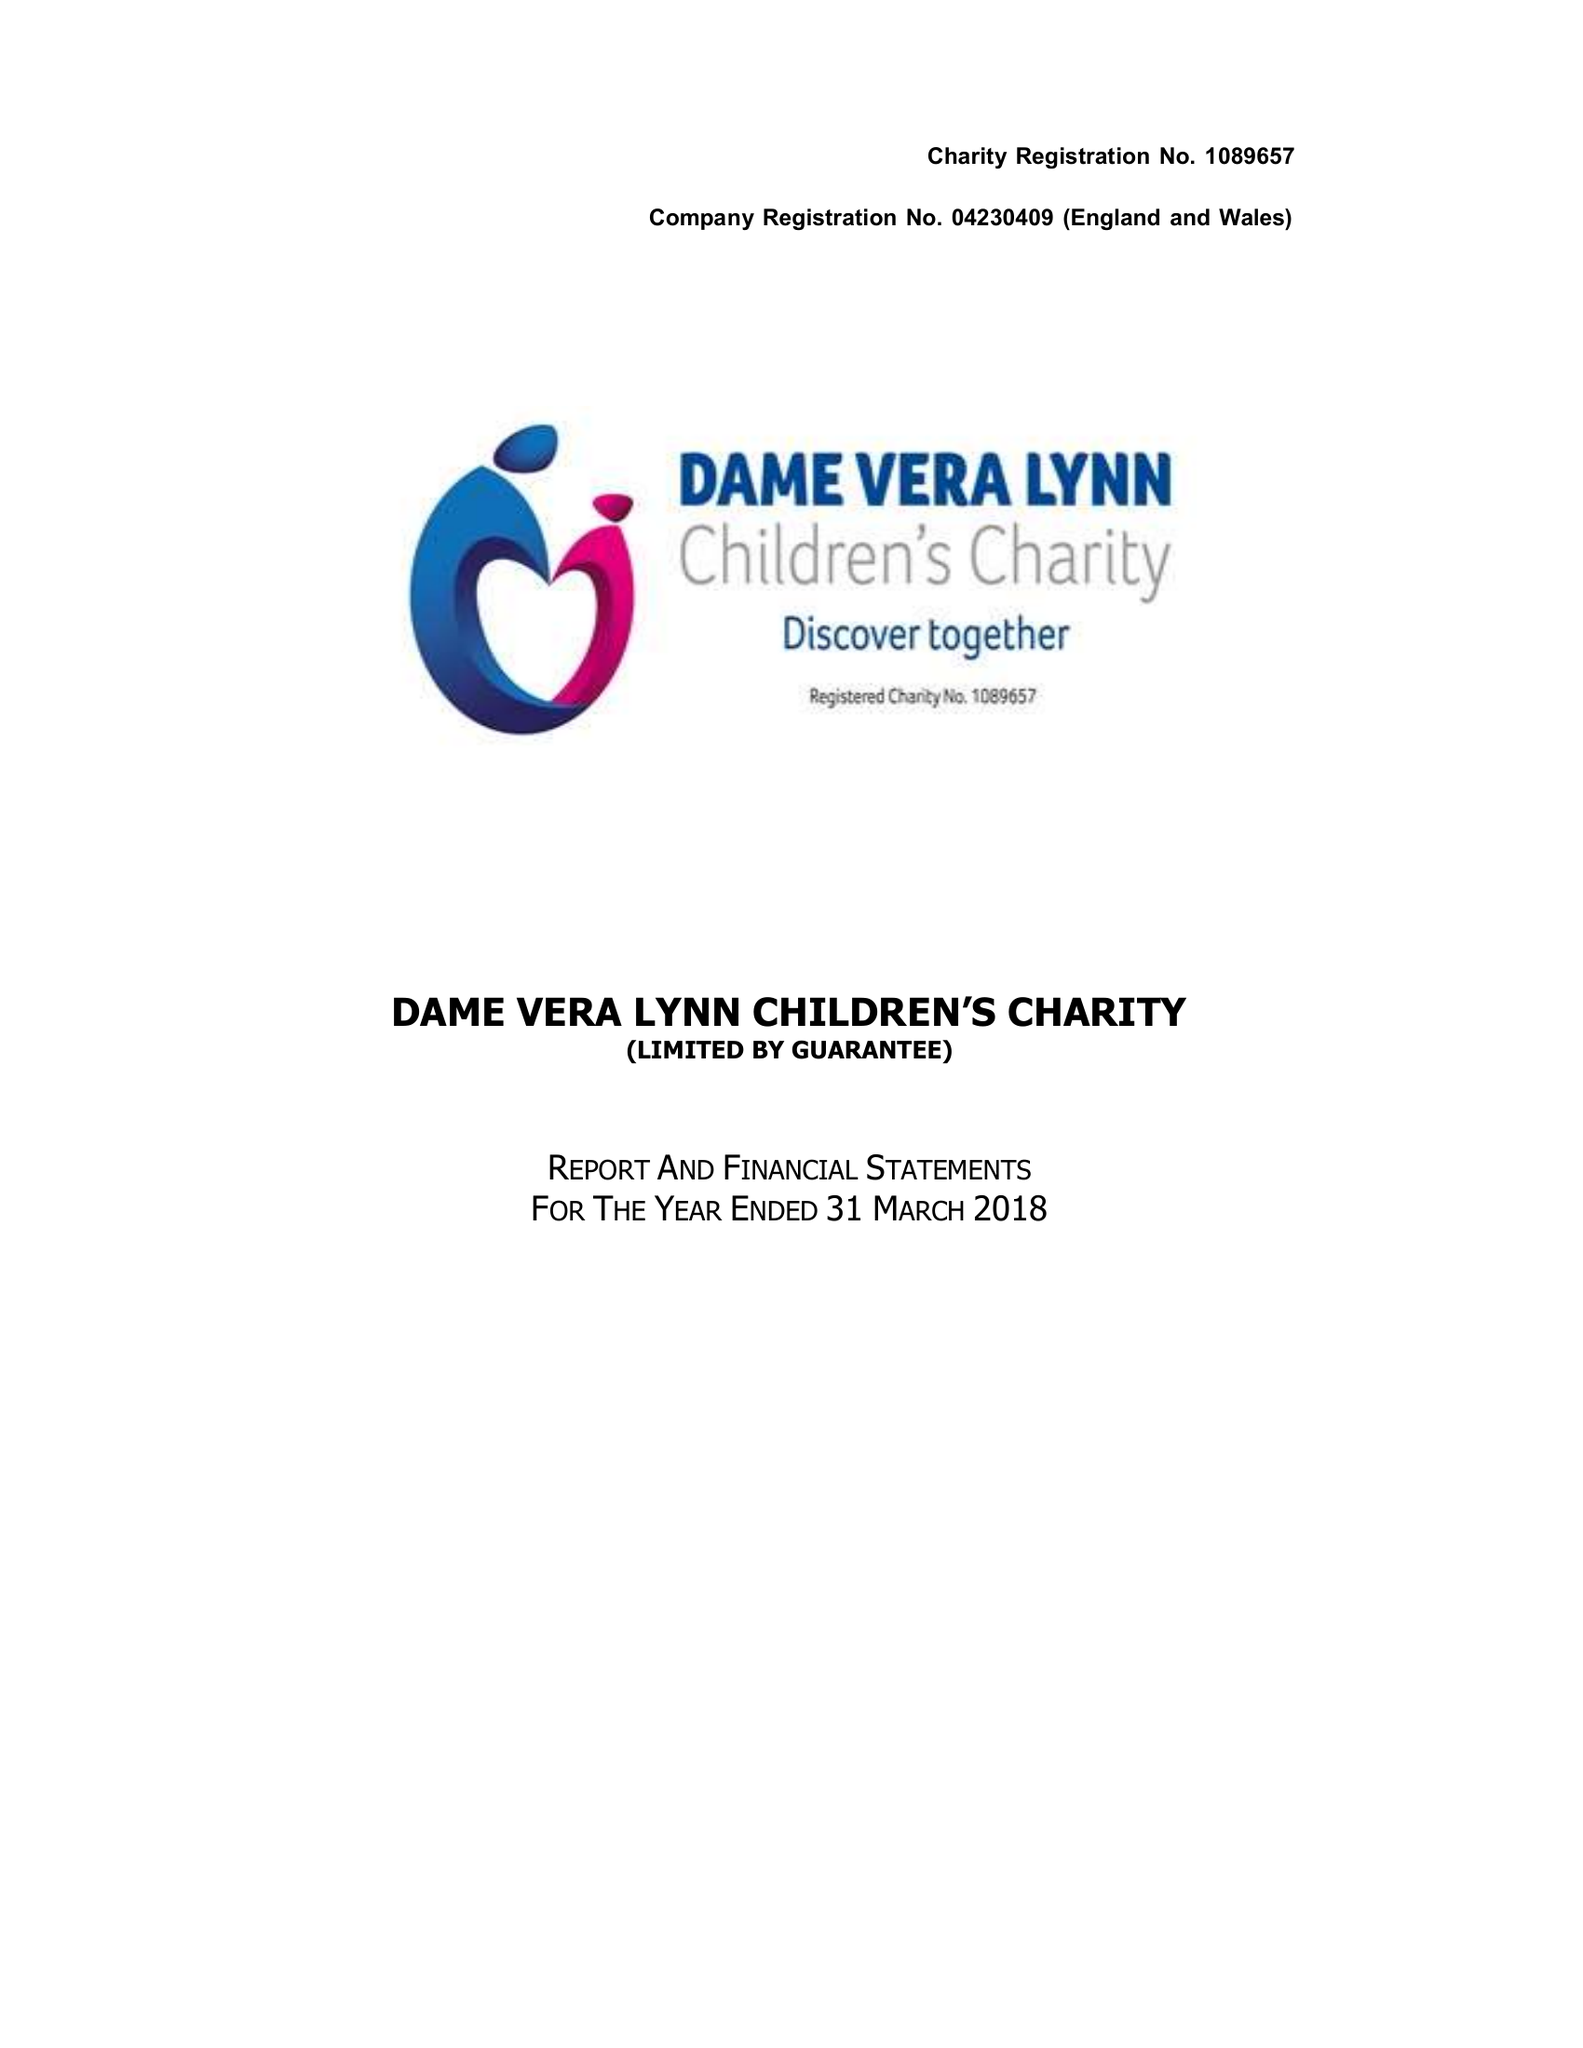What is the value for the address__post_town?
Answer the question using a single word or phrase. HAYWARDS HEATH 